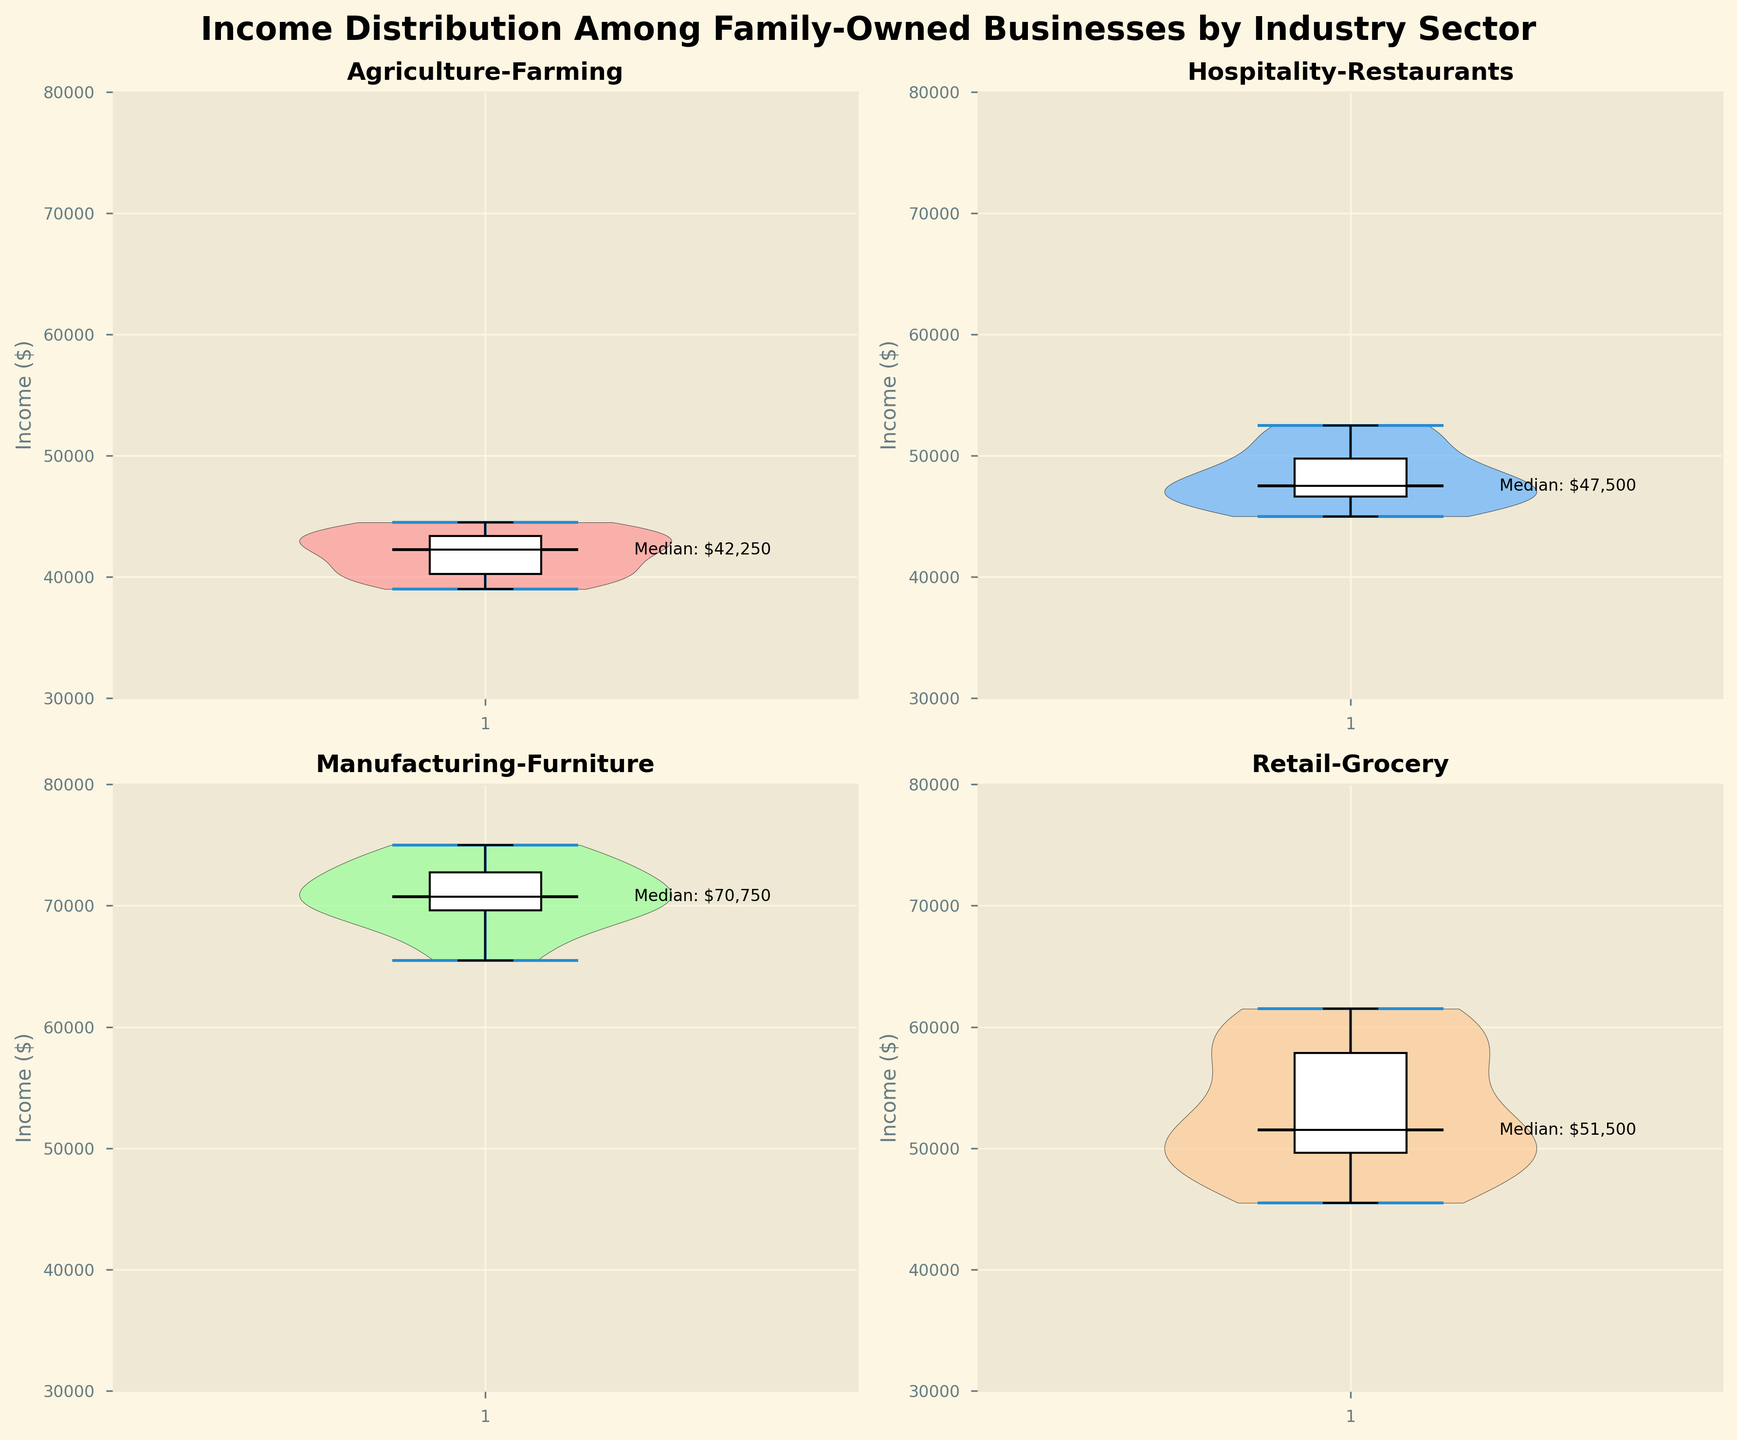What's the median income for family-owned businesses in the Retail-Grocery sector? Look at the subfigure titled "Retail-Grocery" and locate the black line in the middle of the violin plot. According to the figure, the median value is labeled near the black line, showing $52,500.
Answer: $52,500 What is the range of incomes for Manufacturing-Furniture? Examine the range of the violin plot under "Manufacturing-Furniture". The minimum is around $65,500, and the maximum is near $75,000 creating a range of $75,000 - $65,500 = $9,500.
Answer: $9,500 Which sector has the lowest median income? Identify the black lines (medians) in each subplot and read their labels. The "Agriculture-Farming" sector has the lowest median income at $41,000.
Answer: Agriculture-Farming Do Retail-Grocery and Hospitality-Restaurants have overlapping income distributions? Compare the vertical spreads of the violins of both sectors under their respective subfigures. Both the ranges overlap between about $45,000 and $52,500.
Answer: Yes Between which two sectors is the median income closest to each other? Compare the medians by reading the labels next to the black median lines. The medians for "Retail-Grocery" ($52,500) and "Hospitality-Restaurants" ($48,000) are the closest.
Answer: Retail-Grocery and Hospitality-Restaurants What is the median income for Agriculture-Farming, and how does it compare to Manufacturing-Furniture? First, read the median income for "Agriculture-Farming" ($41,000) and "Manufacturing-Furniture" ($71,000). The difference is $71,000 - $41,000 = $30,000.
Answer: $30,000 less Which sector has the widest income distribution? Compare the length of the violin plots. The "Manufacturing-Furniture" sector has the widest spread with a range from $65,500 to $75,000, a total of $9,500.
Answer: Manufacturing-Furniture Which industry sector has the highest maximum income among the family-owned businesses? Look at the top extents of all violin plots. "Manufacturing-Furniture" reaches the highest maximum income at $75,000.
Answer: Manufacturing-Furniture 